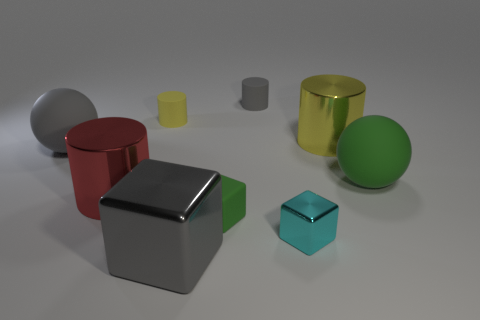How many yellow cylinders must be subtracted to get 1 yellow cylinders? 1 Subtract all purple cylinders. Subtract all gray spheres. How many cylinders are left? 4 Add 1 gray balls. How many objects exist? 10 Subtract all balls. How many objects are left? 7 Subtract 0 brown cylinders. How many objects are left? 9 Subtract all purple matte blocks. Subtract all big red objects. How many objects are left? 8 Add 1 large yellow things. How many large yellow things are left? 2 Add 3 tiny yellow cylinders. How many tiny yellow cylinders exist? 4 